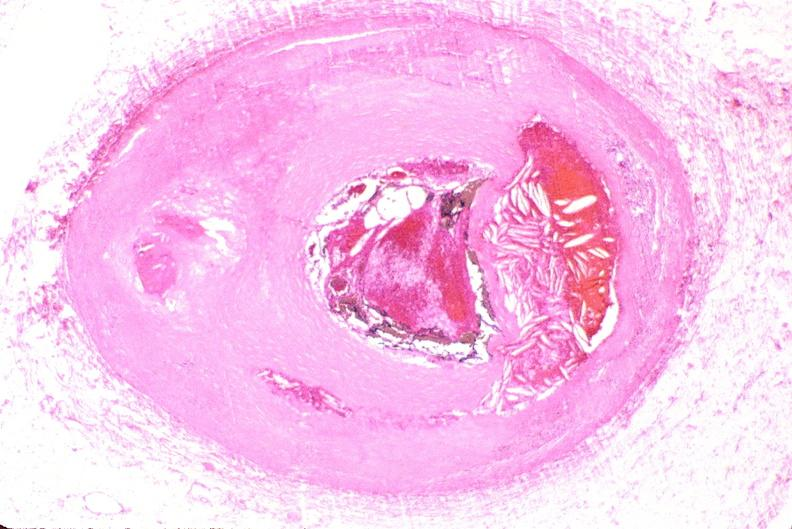does adenocarcinoma show right coronary artery, atherosclerosis and acute thrombus?
Answer the question using a single word or phrase. No 